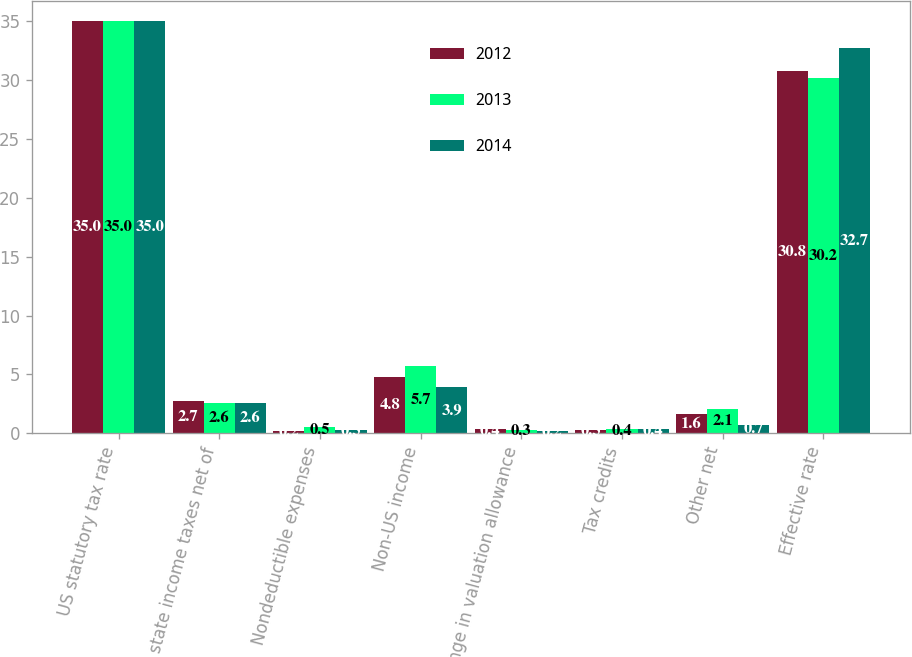Convert chart. <chart><loc_0><loc_0><loc_500><loc_500><stacked_bar_chart><ecel><fcel>US statutory tax rate<fcel>US state income taxes net of<fcel>Nondeductible expenses<fcel>Non-US income<fcel>Change in valuation allowance<fcel>Tax credits<fcel>Other net<fcel>Effective rate<nl><fcel>2012<fcel>35<fcel>2.7<fcel>0.2<fcel>4.8<fcel>0.4<fcel>0.3<fcel>1.6<fcel>30.8<nl><fcel>2013<fcel>35<fcel>2.6<fcel>0.5<fcel>5.7<fcel>0.3<fcel>0.4<fcel>2.1<fcel>30.2<nl><fcel>2014<fcel>35<fcel>2.6<fcel>0.3<fcel>3.9<fcel>0.2<fcel>0.4<fcel>0.7<fcel>32.7<nl></chart> 